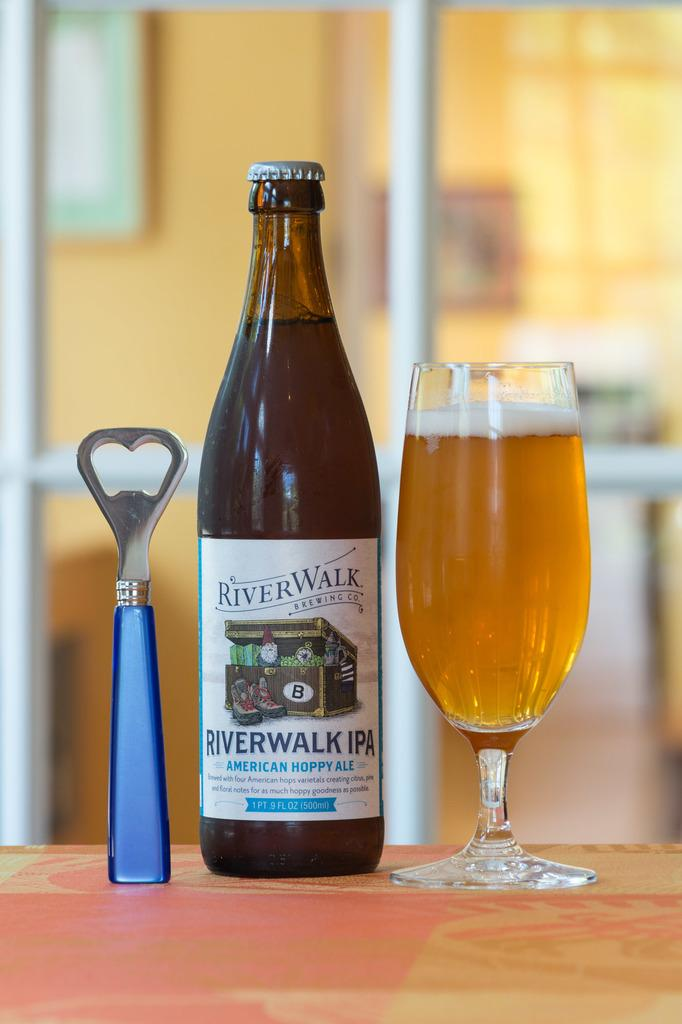What piece of furniture is present in the image? There is a table in the image. What objects can be found on the table? The table contains an opener, a bottle, and a glass. What might be used to open the bottle in the image? The opener on the table can be used to open the bottle. How does the team contribute to the digestion process in the image? There is no team or digestion process present in the image; it only features a table with an opener, bottle, and glass. 